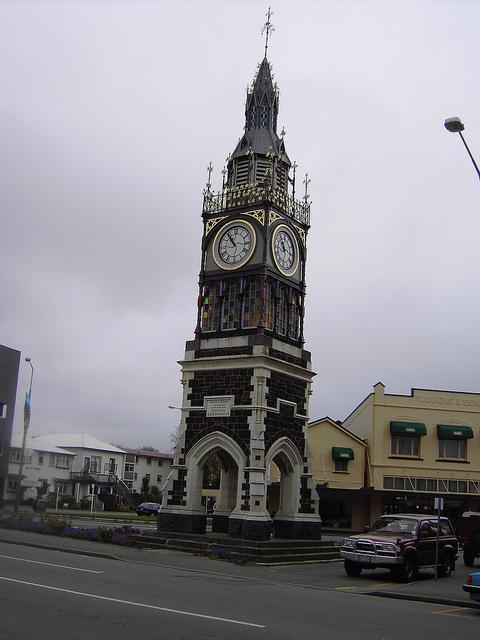How many clocks are there?
Give a very brief answer. 2. 